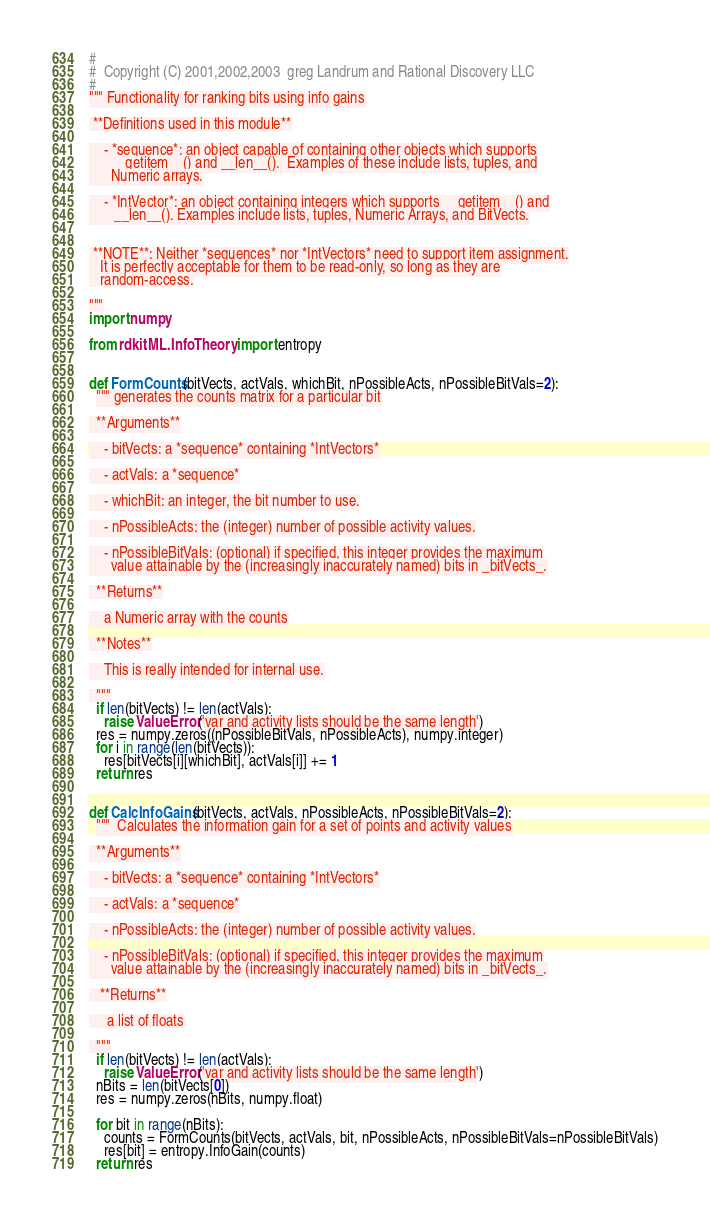<code> <loc_0><loc_0><loc_500><loc_500><_Python_>#
#  Copyright (C) 2001,2002,2003  greg Landrum and Rational Discovery LLC
#
""" Functionality for ranking bits using info gains

 **Definitions used in this module**

    - *sequence*: an object capable of containing other objects which supports
      __getitem__() and __len__().  Examples of these include lists, tuples, and
      Numeric arrays.

    - *IntVector*: an object containing integers which supports __getitem__() and
       __len__(). Examples include lists, tuples, Numeric Arrays, and BitVects.


 **NOTE**: Neither *sequences* nor *IntVectors* need to support item assignment.
   It is perfectly acceptable for them to be read-only, so long as they are
   random-access.

"""
import numpy

from rdkit.ML.InfoTheory import entropy


def FormCounts(bitVects, actVals, whichBit, nPossibleActs, nPossibleBitVals=2):
  """ generates the counts matrix for a particular bit

  **Arguments**

    - bitVects: a *sequence* containing *IntVectors*

    - actVals: a *sequence*

    - whichBit: an integer, the bit number to use.

    - nPossibleActs: the (integer) number of possible activity values.

    - nPossibleBitVals: (optional) if specified, this integer provides the maximum
      value attainable by the (increasingly inaccurately named) bits in _bitVects_.

  **Returns**

    a Numeric array with the counts

  **Notes**

    This is really intended for internal use.

  """
  if len(bitVects) != len(actVals):
    raise ValueError('var and activity lists should be the same length')
  res = numpy.zeros((nPossibleBitVals, nPossibleActs), numpy.integer)
  for i in range(len(bitVects)):
    res[bitVects[i][whichBit], actVals[i]] += 1
  return res


def CalcInfoGains(bitVects, actVals, nPossibleActs, nPossibleBitVals=2):
  """  Calculates the information gain for a set of points and activity values

  **Arguments**

    - bitVects: a *sequence* containing *IntVectors*

    - actVals: a *sequence*

    - nPossibleActs: the (integer) number of possible activity values.

    - nPossibleBitVals: (optional) if specified, this integer provides the maximum
      value attainable by the (increasingly inaccurately named) bits in _bitVects_.

   **Returns**

     a list of floats

  """
  if len(bitVects) != len(actVals):
    raise ValueError('var and activity lists should be the same length')
  nBits = len(bitVects[0])
  res = numpy.zeros(nBits, numpy.float)

  for bit in range(nBits):
    counts = FormCounts(bitVects, actVals, bit, nPossibleActs, nPossibleBitVals=nPossibleBitVals)
    res[bit] = entropy.InfoGain(counts)
  return res

</code> 